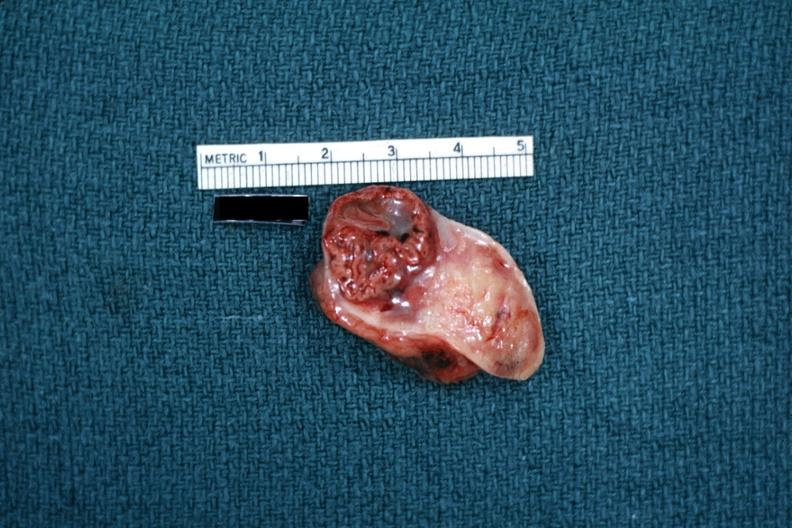s corpus luteum present?
Answer the question using a single word or phrase. Yes 